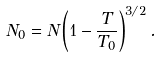Convert formula to latex. <formula><loc_0><loc_0><loc_500><loc_500>N _ { 0 } = N \left ( 1 - \frac { T } { T _ { 0 } } \right ) ^ { 3 / 2 } .</formula> 